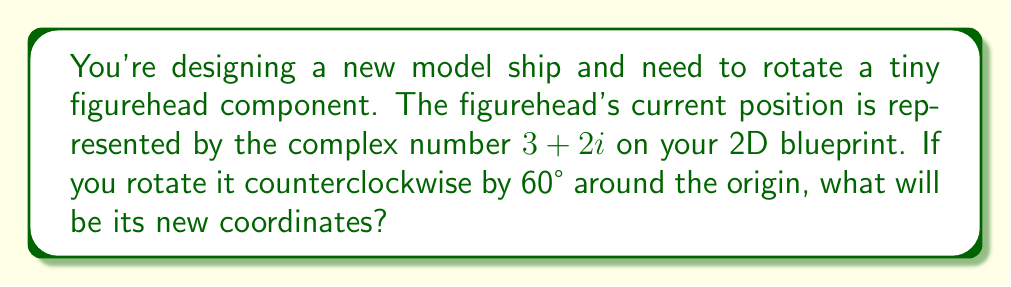Can you answer this question? To solve this problem, we'll use the complex number rotation formula:

$z' = z \cdot (\cos \theta + i \sin \theta)$

Where:
- $z$ is the original complex number
- $\theta$ is the angle of rotation in radians
- $z'$ is the resulting complex number after rotation

Step 1: Convert the angle from degrees to radians
$$60° = \frac{60 \cdot \pi}{180} = \frac{\pi}{3} \text{ radians}$$

Step 2: Calculate $\cos \frac{\pi}{3}$ and $\sin \frac{\pi}{3}$
$$\cos \frac{\pi}{3} = \frac{1}{2}$$
$$\sin \frac{\pi}{3} = \frac{\sqrt{3}}{2}$$

Step 3: Apply the rotation formula
$$\begin{align}
z' &= (3+2i) \cdot (\cos \frac{\pi}{3} + i \sin \frac{\pi}{3}) \\
&= (3+2i) \cdot (\frac{1}{2} + i \frac{\sqrt{3}}{2}) \\
&= (3+2i) \cdot \frac{1}{2} + (3+2i) \cdot i \frac{\sqrt{3}}{2} \\
&= (\frac{3}{2} + i) + (i\frac{3\sqrt{3}}{2} - \sqrt{3}) \\
&= \frac{3}{2} - \sqrt{3} + i(1 + \frac{3\sqrt{3}}{2})
\end{align}$$

Step 4: Simplify and separate real and imaginary parts
$$z' = (\frac{3}{2} - \sqrt{3}) + i(\frac{3\sqrt{3}}{2} + 1)$$

The new coordinates are $(\frac{3}{2} - \sqrt{3}, \frac{3\sqrt{3}}{2} + 1)$.
Answer: $(\frac{3}{2} - \sqrt{3}, \frac{3\sqrt{3}}{2} + 1)$ 